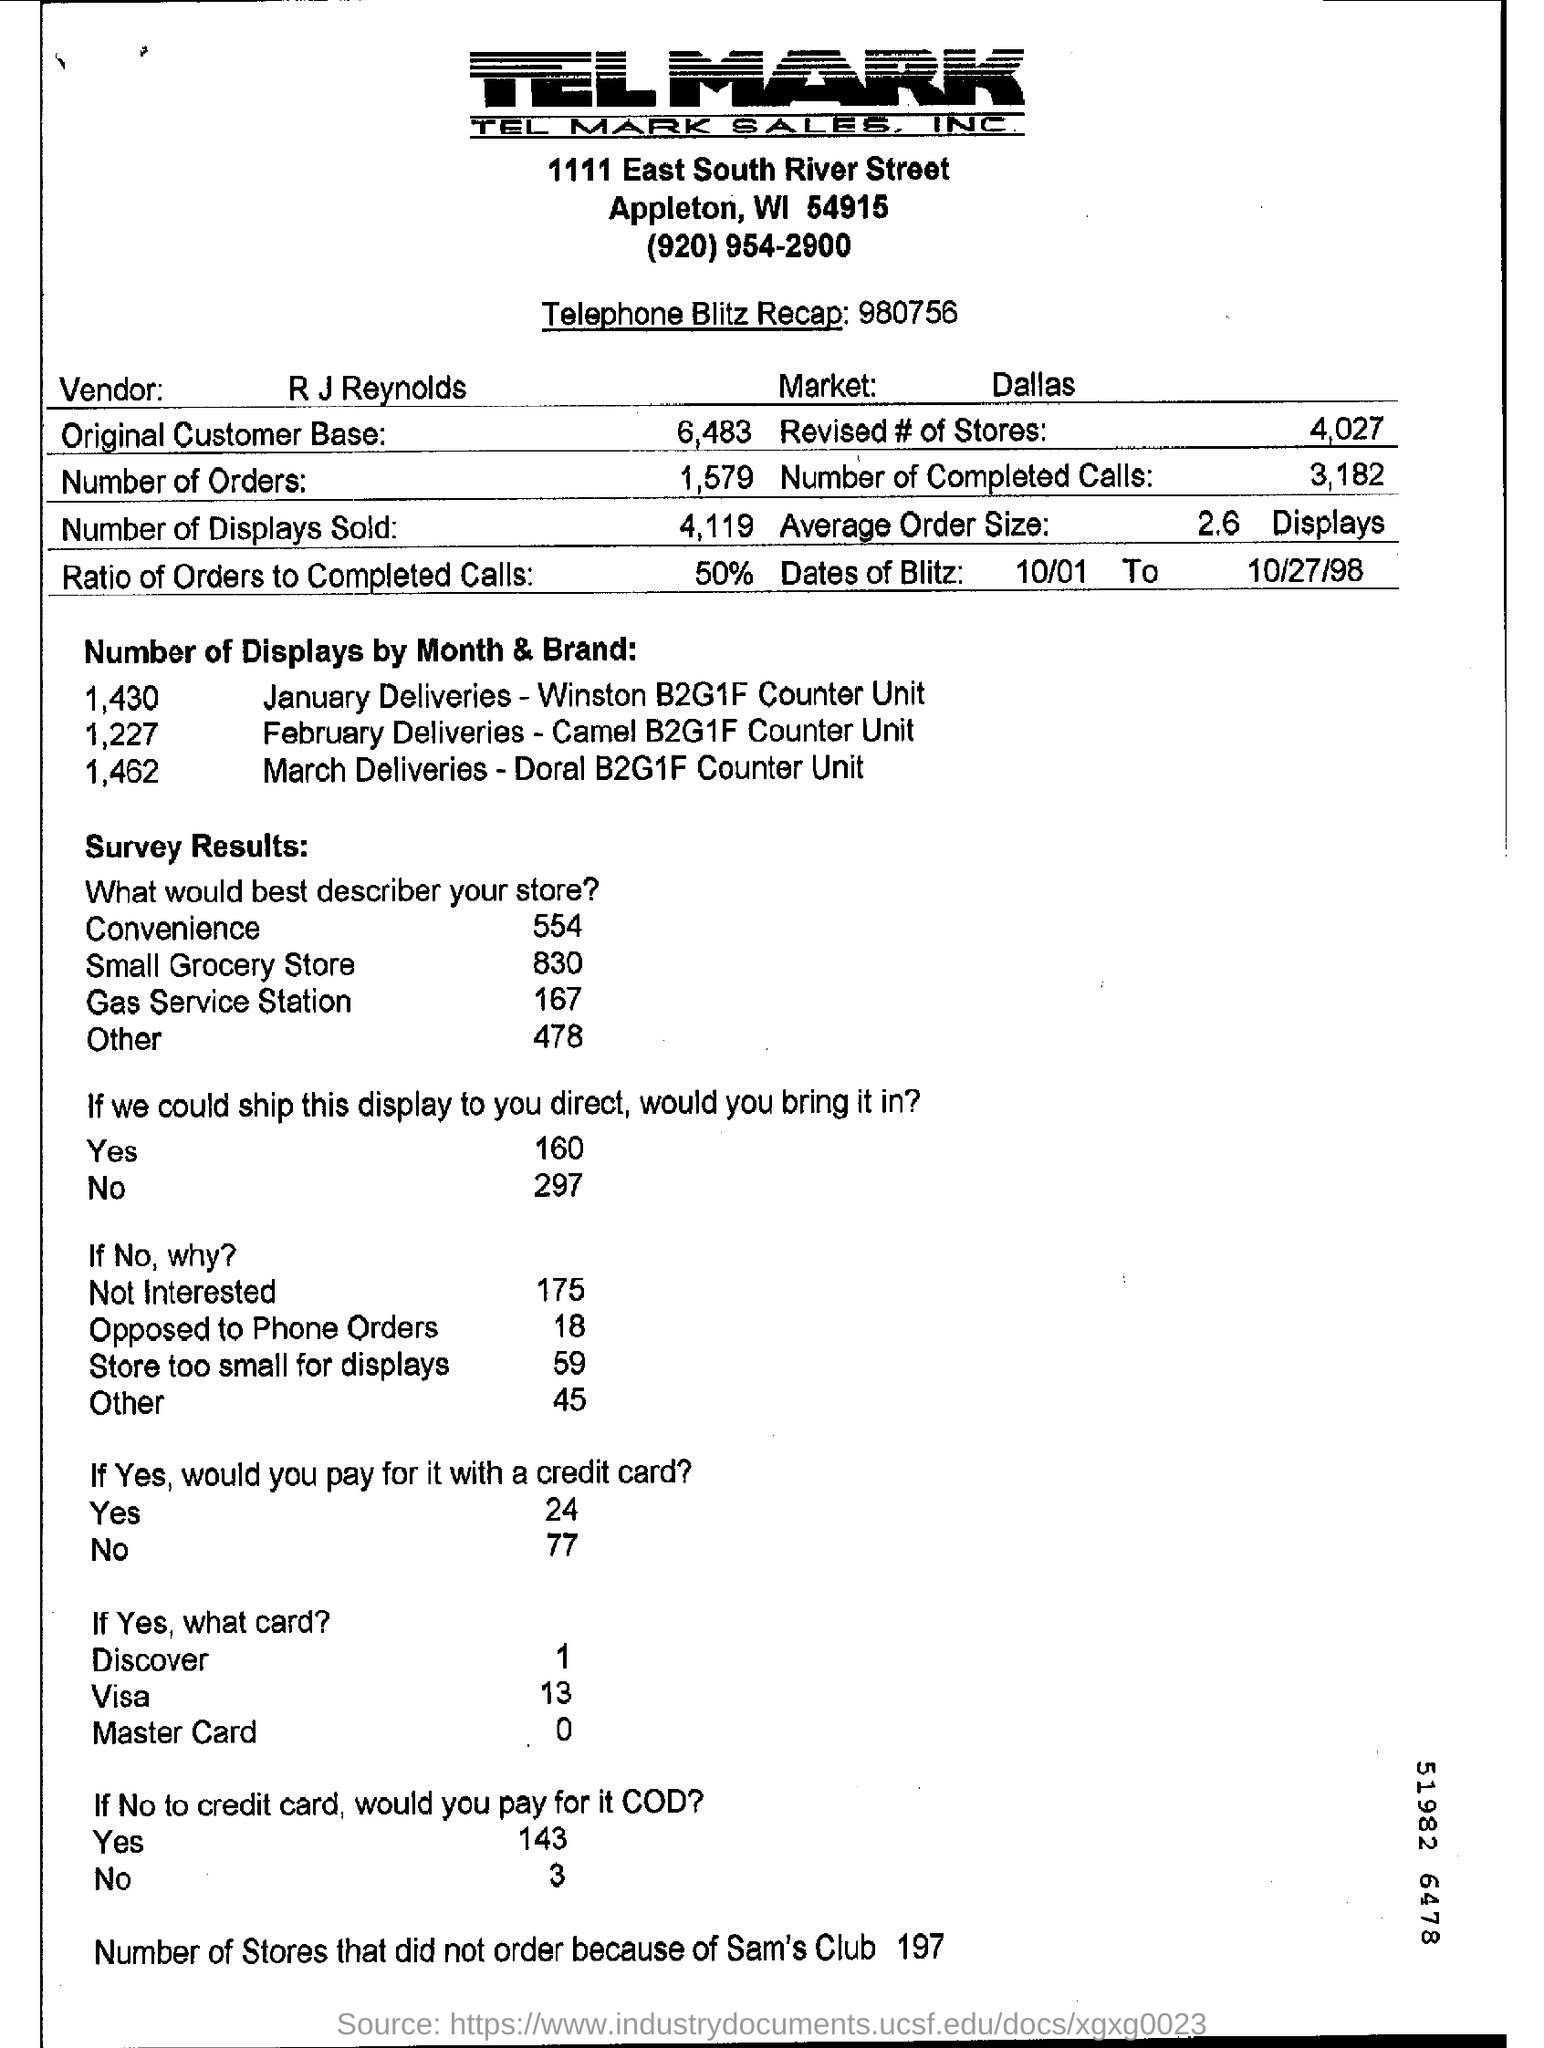What is the Ratio of Orders to Completed Calls ?
Ensure brevity in your answer.  50%. Who is the vendor ?
Your answer should be compact. R J REYNOLDS. What are the Number of Orders ?
Give a very brief answer. 1579. 